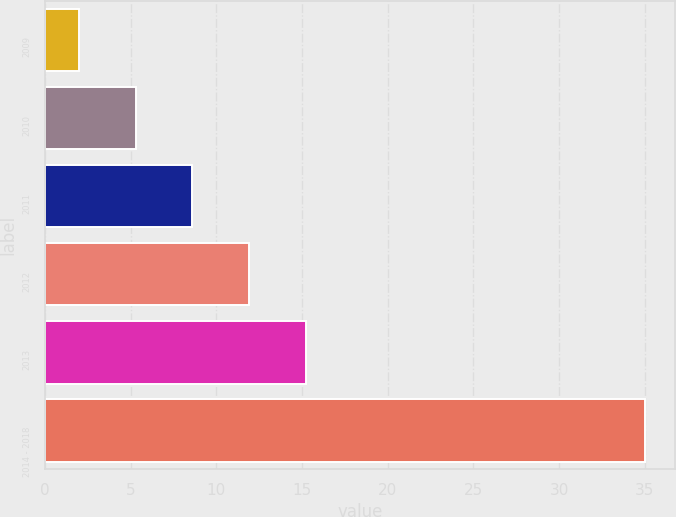Convert chart. <chart><loc_0><loc_0><loc_500><loc_500><bar_chart><fcel>2009<fcel>2010<fcel>2011<fcel>2012<fcel>2013<fcel>2014 - 2018<nl><fcel>2<fcel>5.3<fcel>8.6<fcel>11.9<fcel>15.2<fcel>35<nl></chart> 